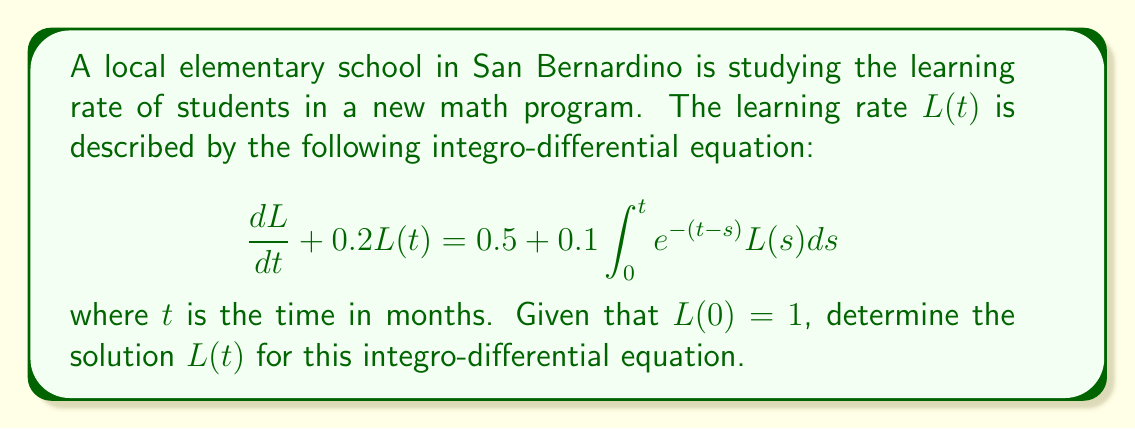Provide a solution to this math problem. To solve this integro-differential equation, we'll use the Laplace transform method:

1) Take the Laplace transform of both sides:
   $$\mathcal{L}\left\{\frac{dL}{dt}\right\} + 0.2\mathcal{L}\{L(t)\} = \mathcal{L}\{0.5\} + 0.1\mathcal{L}\left\{\int_0^t e^{-(t-s)}L(s)ds\right\}$$

2) Using Laplace transform properties:
   $$s\bar{L}(s) - L(0) + 0.2\bar{L}(s) = \frac{0.5}{s} + 0.1\bar{L}(s)\frac{1}{s+1}$$

3) Substitute $L(0) = 1$ and simplify:
   $$s\bar{L}(s) - 1 + 0.2\bar{L}(s) = \frac{0.5}{s} + \frac{0.1\bar{L}(s)}{s+1}$$

4) Collect terms with $\bar{L}(s)$:
   $$\bar{L}(s)\left(s + 0.2 - \frac{0.1}{s+1}\right) = 1 + \frac{0.5}{s}$$

5) Solve for $\bar{L}(s)$:
   $$\bar{L}(s) = \frac{1 + \frac{0.5}{s}}{s + 0.2 - \frac{0.1}{s+1}}$$

6) Simplify the denominator:
   $$\bar{L}(s) = \frac{s + 0.5}{s^2 + 1.2s + 0.1}$$

7) Use partial fraction decomposition:
   $$\bar{L}(s) = \frac{A}{s + 0.1} + \frac{B}{s + 1.1}$$

   where $A = 0.9091$ and $B = 0.0909$ (calculated values)

8) Take the inverse Laplace transform:
   $$L(t) = 0.9091e^{-0.1t} + 0.0909e^{-1.1t}$$

This is the solution to the integro-differential equation describing the learning rate pattern.
Answer: $L(t) = 0.9091e^{-0.1t} + 0.0909e^{-1.1t}$ 